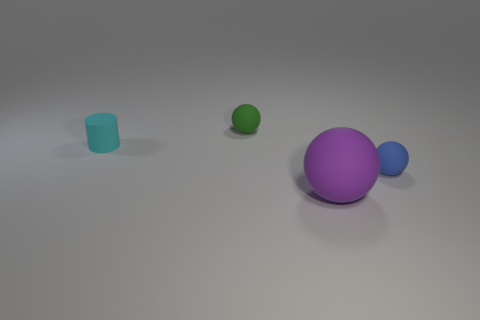There is a green object behind the tiny matte cylinder; is there a small blue matte sphere behind it?
Make the answer very short. No. Are there fewer small blue balls that are left of the big purple thing than tiny blue things right of the small green matte thing?
Make the answer very short. Yes. What number of tiny objects are either purple rubber spheres or matte objects?
Your response must be concise. 3. There is a blue object that is made of the same material as the big purple thing; what is its shape?
Make the answer very short. Sphere. Is the number of cyan cylinders that are on the left side of the cylinder less than the number of tiny matte balls?
Give a very brief answer. Yes. Is the shape of the small green thing the same as the cyan object?
Offer a very short reply. No. How many matte objects are tiny gray spheres or large purple spheres?
Your response must be concise. 1. Is there a cyan thing that has the same size as the green rubber object?
Offer a terse response. Yes. How many green matte spheres have the same size as the green thing?
Keep it short and to the point. 0. Does the matte ball that is in front of the tiny blue sphere have the same size as the rubber ball behind the small cyan cylinder?
Make the answer very short. No. 